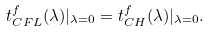<formula> <loc_0><loc_0><loc_500><loc_500>t _ { C F L } ^ { f } ( \lambda ) | _ { \lambda = 0 } = t _ { C H } ^ { f } ( \lambda ) | _ { \lambda = 0 } .</formula> 